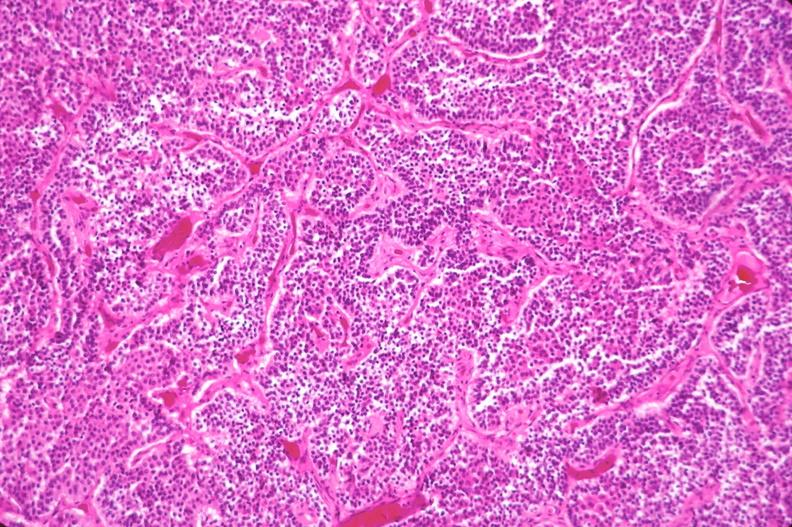does this image show pituitary, chromaphobe adenoma?
Answer the question using a single word or phrase. Yes 